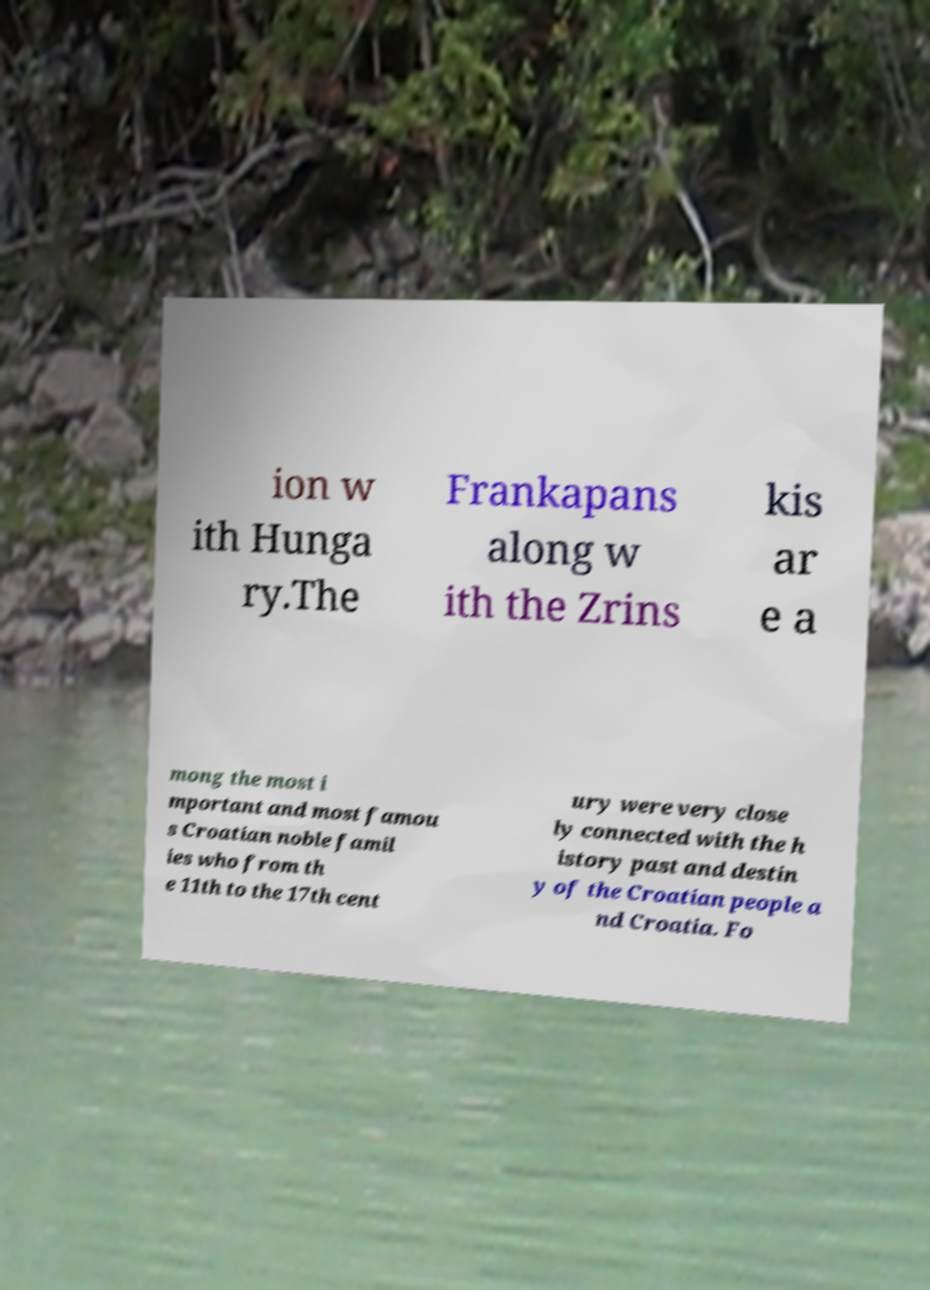Could you extract and type out the text from this image? ion w ith Hunga ry.The Frankapans along w ith the Zrins kis ar e a mong the most i mportant and most famou s Croatian noble famil ies who from th e 11th to the 17th cent ury were very close ly connected with the h istory past and destin y of the Croatian people a nd Croatia. Fo 